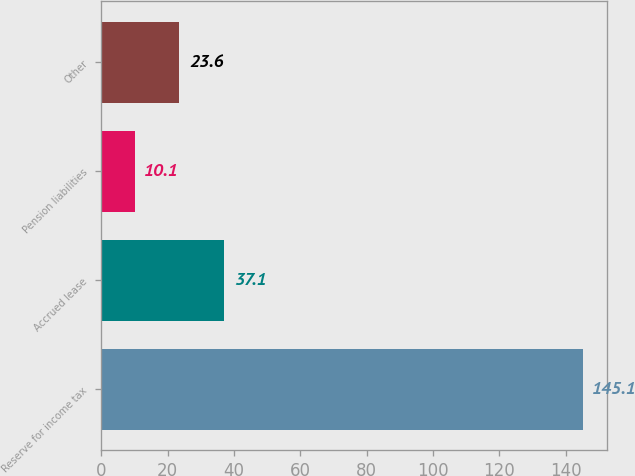Convert chart. <chart><loc_0><loc_0><loc_500><loc_500><bar_chart><fcel>Reserve for income tax<fcel>Accrued lease<fcel>Pension liabilities<fcel>Other<nl><fcel>145.1<fcel>37.1<fcel>10.1<fcel>23.6<nl></chart> 